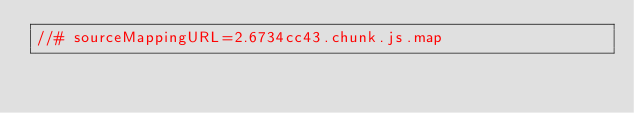Convert code to text. <code><loc_0><loc_0><loc_500><loc_500><_JavaScript_>//# sourceMappingURL=2.6734cc43.chunk.js.map</code> 